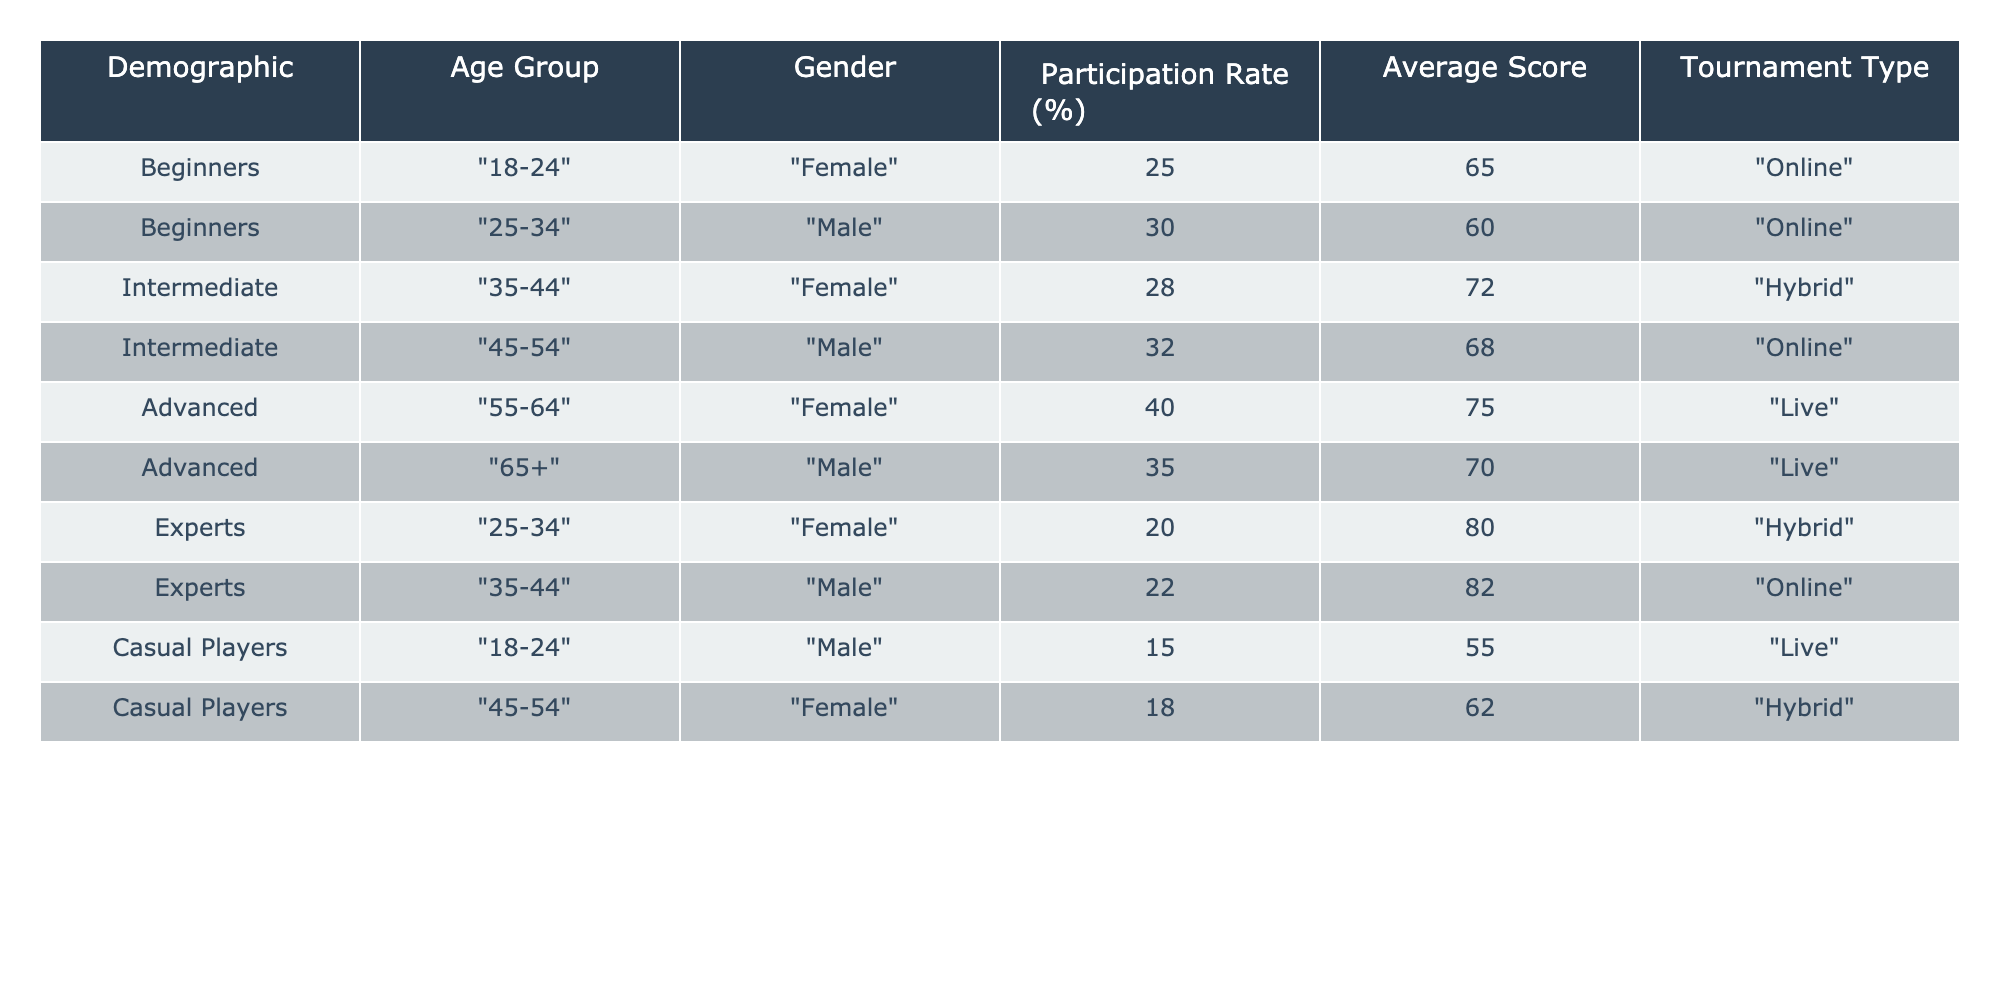What is the highest participation rate and which demographic does it belong to? The highest participation rate is 40%, which belongs to the "Advanced" demographic in the "55-64" age group of females playing in "Live" tournaments.
Answer: 40%, Advanced, 55-64, Female What is the average score of players in the "Casual Players" demographic? For the "Casual Players," the scores are 55 (Male, 18-24) and 62 (Female, 45-54). The average score is (55 + 62) / 2 = 58.5.
Answer: 58.5 Is there a male player in the "Beginners" category? Yes, there is a male player in the "Beginners" category who is in the "25-34" age group with a participation rate of 30%.
Answer: Yes Which age group has the highest average score and what is that score? The "Advanced" age group has the highest average score of 75, belonging to the "55-64" age group of females playing in "Live" tournaments.
Answer: 75, Advanced What is the difference in participation rates between "Beginners" and "Advanced" players? The participation rate for "Beginners" is (25 + 30) / 2 = 27.5%, while for "Advanced," it is (40 + 35) / 2 = 37.5%. The difference is 37.5 - 27.5 = 10%.
Answer: 10% How many female players participated in "Hybrid" tournaments across all skill levels? In "Hybrid" tournaments, there are two female players: one from the "Intermediate" level (score of 72) and one from the "Beginners" category (the average score is unknown). Therefore, the total count is 2.
Answer: 2 Which demographic has the lowest average score, and what is that score? The "Casual Players" demographic has the lowest average score of 58.5 (calculated from scores 55 and 62).
Answer: 58.5, Casual Players How many total players participated in "Online" tournaments? The "Online" tournaments feature participants from "Beginners" with 30 and 25, "Intermediate" with 32, and "Experts" with 22 scores. Therefore, there are a total of 30 + 25 + 32 + 22 = 109 participants in "Online" tournaments.
Answer: 109 Which age group has the highest participation rate among male players, and what is that rate? The "45-54" age group of male players in "Online" tournaments has the highest participation rate of 32%.
Answer: 32%, 45-54 Are there more male or female players in the "Advanced" demographic? There are more female players (one at 40%) compared to male players (one at 35%) in the "Advanced" demographic: thus, females outnumber males.
Answer: Female 